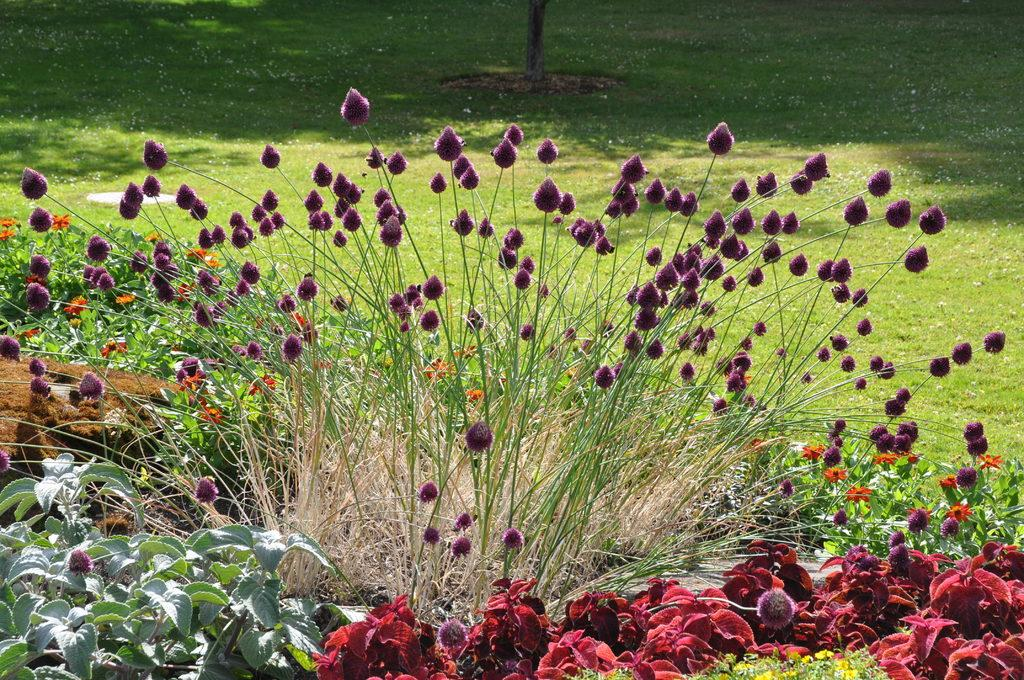What types of living organisms can be seen in the image? Plants and flowers are visible in the image. What color are the flowers in the image? The flowers are violet in color. What can be seen in the background of the image? There is a tree in the background of the image. What is visible at the bottom of the image? Ground is visible at the bottom of the image. How many brothers are depicted in the image? There are no brothers present in the image; it features plants, flowers, a tree, and ground. Can you tell me where the owl is perched in the image? There is no owl present in the image. 